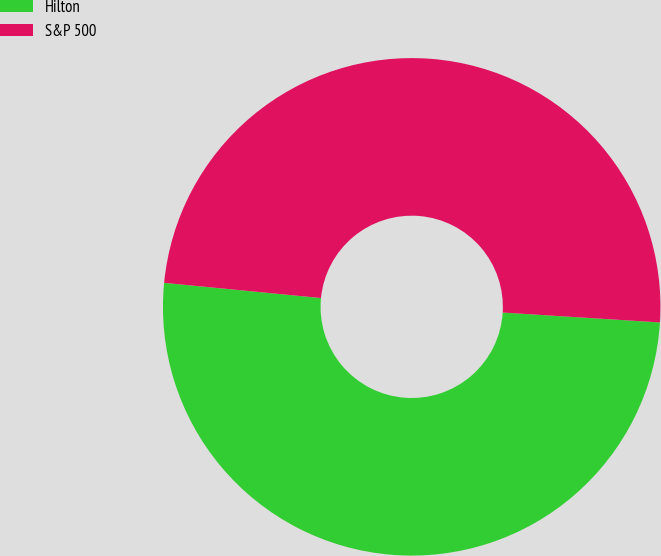Convert chart. <chart><loc_0><loc_0><loc_500><loc_500><pie_chart><fcel>Hilton<fcel>S&P 500<nl><fcel>50.54%<fcel>49.46%<nl></chart> 